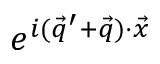Convert formula to latex. <formula><loc_0><loc_0><loc_500><loc_500>e ^ { i ( \vec { q } ^ { \prime } + \vec { q } ) \cdot \vec { x } }</formula> 